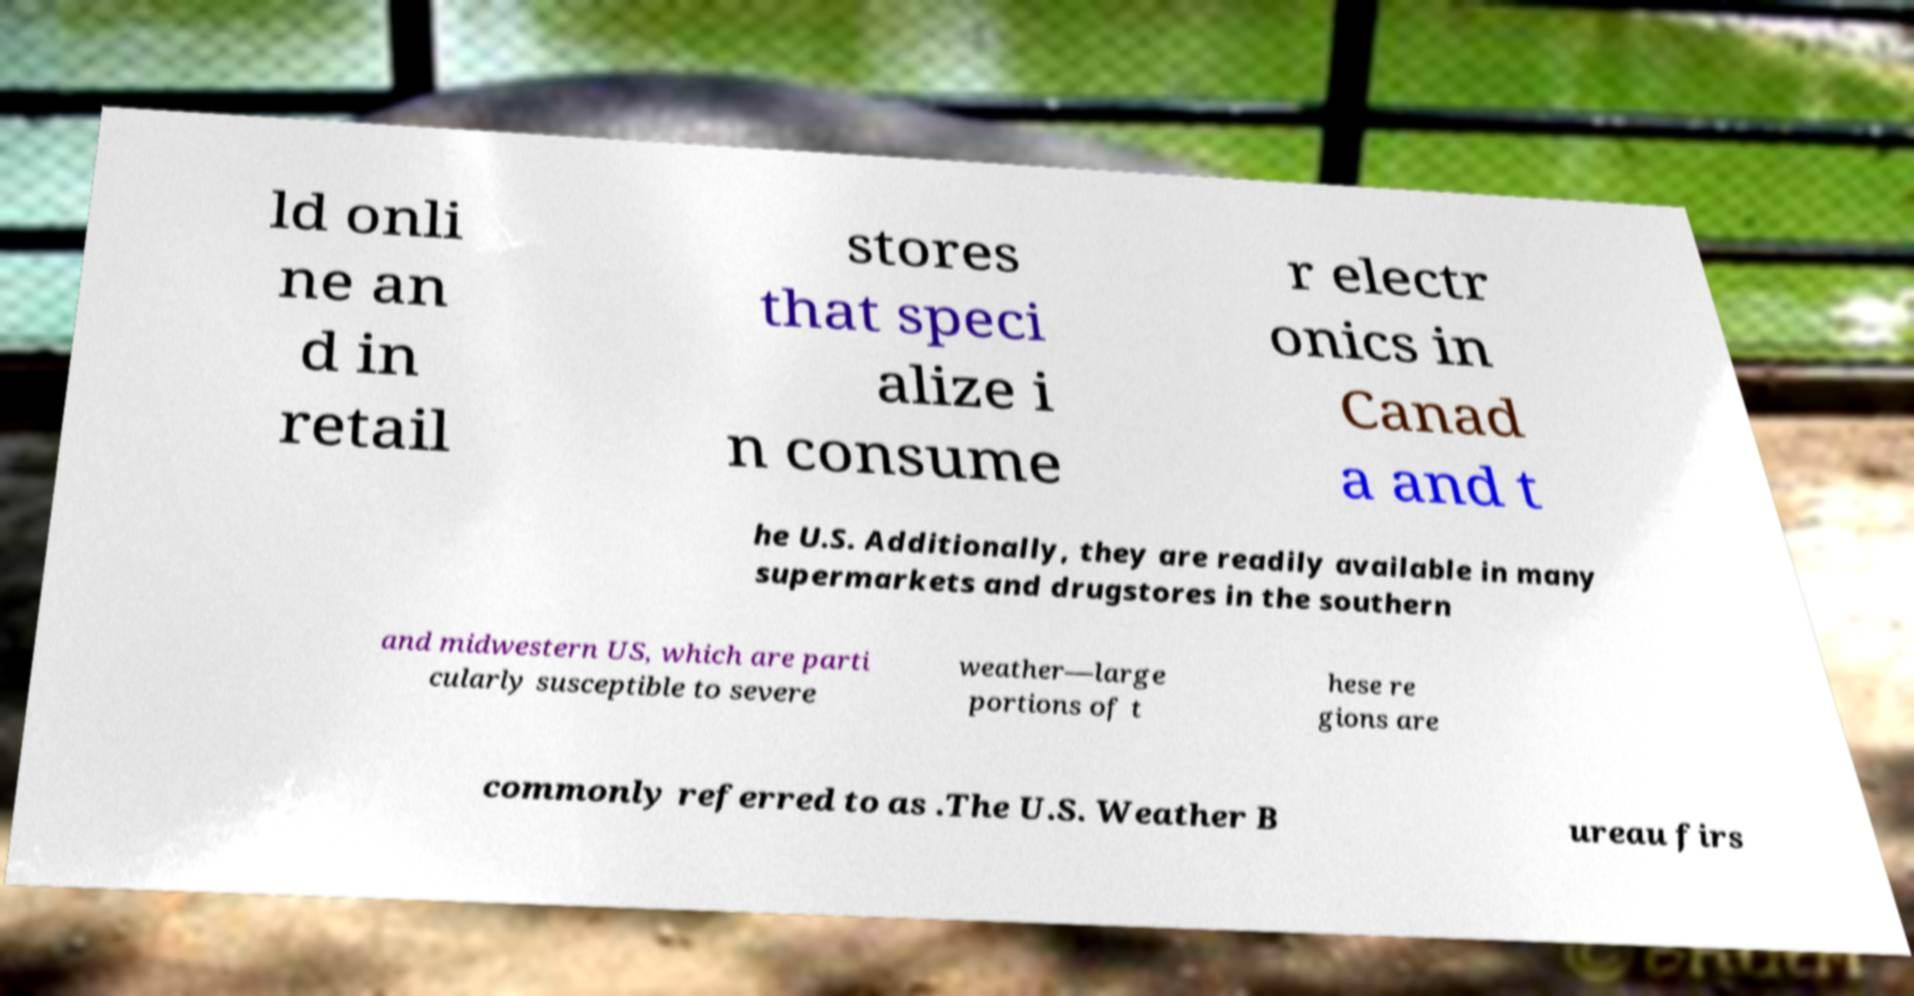Could you assist in decoding the text presented in this image and type it out clearly? ld onli ne an d in retail stores that speci alize i n consume r electr onics in Canad a and t he U.S. Additionally, they are readily available in many supermarkets and drugstores in the southern and midwestern US, which are parti cularly susceptible to severe weather—large portions of t hese re gions are commonly referred to as .The U.S. Weather B ureau firs 